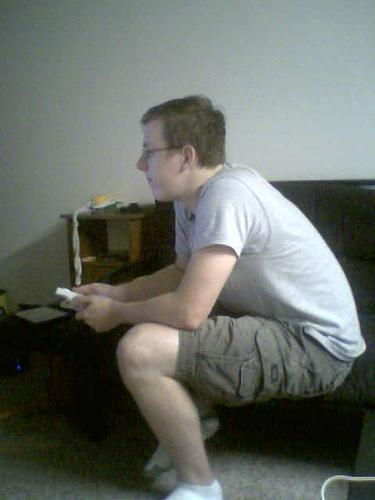What type of furniture is the boy sitting on? Please explain your reasoning. futon. It is a couch that resembles a mattress and is low to the ground. it is a common piece of furniture used by people this age. 